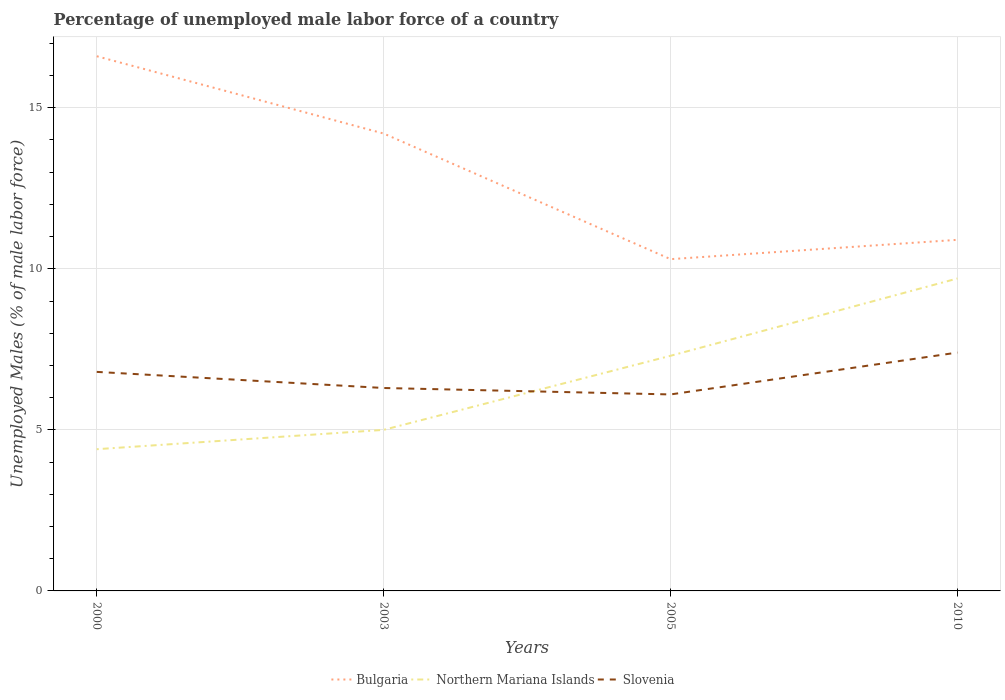How many different coloured lines are there?
Provide a succinct answer. 3. Is the number of lines equal to the number of legend labels?
Your response must be concise. Yes. Across all years, what is the maximum percentage of unemployed male labor force in Northern Mariana Islands?
Give a very brief answer. 4.4. What is the total percentage of unemployed male labor force in Northern Mariana Islands in the graph?
Your answer should be compact. -2.4. What is the difference between the highest and the second highest percentage of unemployed male labor force in Bulgaria?
Offer a very short reply. 6.3. What is the difference between the highest and the lowest percentage of unemployed male labor force in Northern Mariana Islands?
Your answer should be compact. 2. Is the percentage of unemployed male labor force in Slovenia strictly greater than the percentage of unemployed male labor force in Bulgaria over the years?
Your answer should be compact. Yes. How many lines are there?
Your answer should be very brief. 3. How many years are there in the graph?
Give a very brief answer. 4. Does the graph contain any zero values?
Provide a short and direct response. No. Does the graph contain grids?
Offer a very short reply. Yes. How many legend labels are there?
Give a very brief answer. 3. How are the legend labels stacked?
Provide a succinct answer. Horizontal. What is the title of the graph?
Offer a terse response. Percentage of unemployed male labor force of a country. What is the label or title of the Y-axis?
Offer a terse response. Unemployed Males (% of male labor force). What is the Unemployed Males (% of male labor force) in Bulgaria in 2000?
Make the answer very short. 16.6. What is the Unemployed Males (% of male labor force) in Northern Mariana Islands in 2000?
Your answer should be very brief. 4.4. What is the Unemployed Males (% of male labor force) of Slovenia in 2000?
Your answer should be compact. 6.8. What is the Unemployed Males (% of male labor force) of Bulgaria in 2003?
Your answer should be very brief. 14.2. What is the Unemployed Males (% of male labor force) of Slovenia in 2003?
Offer a terse response. 6.3. What is the Unemployed Males (% of male labor force) in Bulgaria in 2005?
Provide a short and direct response. 10.3. What is the Unemployed Males (% of male labor force) of Northern Mariana Islands in 2005?
Offer a very short reply. 7.3. What is the Unemployed Males (% of male labor force) of Slovenia in 2005?
Give a very brief answer. 6.1. What is the Unemployed Males (% of male labor force) of Bulgaria in 2010?
Make the answer very short. 10.9. What is the Unemployed Males (% of male labor force) in Northern Mariana Islands in 2010?
Make the answer very short. 9.7. What is the Unemployed Males (% of male labor force) in Slovenia in 2010?
Make the answer very short. 7.4. Across all years, what is the maximum Unemployed Males (% of male labor force) of Bulgaria?
Offer a very short reply. 16.6. Across all years, what is the maximum Unemployed Males (% of male labor force) in Northern Mariana Islands?
Make the answer very short. 9.7. Across all years, what is the maximum Unemployed Males (% of male labor force) in Slovenia?
Your response must be concise. 7.4. Across all years, what is the minimum Unemployed Males (% of male labor force) of Bulgaria?
Keep it short and to the point. 10.3. Across all years, what is the minimum Unemployed Males (% of male labor force) of Northern Mariana Islands?
Ensure brevity in your answer.  4.4. Across all years, what is the minimum Unemployed Males (% of male labor force) in Slovenia?
Your response must be concise. 6.1. What is the total Unemployed Males (% of male labor force) in Northern Mariana Islands in the graph?
Ensure brevity in your answer.  26.4. What is the total Unemployed Males (% of male labor force) of Slovenia in the graph?
Offer a very short reply. 26.6. What is the difference between the Unemployed Males (% of male labor force) of Bulgaria in 2000 and that in 2003?
Provide a succinct answer. 2.4. What is the difference between the Unemployed Males (% of male labor force) of Northern Mariana Islands in 2000 and that in 2003?
Keep it short and to the point. -0.6. What is the difference between the Unemployed Males (% of male labor force) of Slovenia in 2000 and that in 2003?
Provide a short and direct response. 0.5. What is the difference between the Unemployed Males (% of male labor force) in Bulgaria in 2000 and that in 2005?
Your answer should be compact. 6.3. What is the difference between the Unemployed Males (% of male labor force) in Northern Mariana Islands in 2000 and that in 2005?
Provide a succinct answer. -2.9. What is the difference between the Unemployed Males (% of male labor force) in Bulgaria in 2000 and that in 2010?
Provide a succinct answer. 5.7. What is the difference between the Unemployed Males (% of male labor force) of Northern Mariana Islands in 2000 and that in 2010?
Make the answer very short. -5.3. What is the difference between the Unemployed Males (% of male labor force) of Bulgaria in 2003 and that in 2005?
Provide a short and direct response. 3.9. What is the difference between the Unemployed Males (% of male labor force) in Slovenia in 2003 and that in 2005?
Ensure brevity in your answer.  0.2. What is the difference between the Unemployed Males (% of male labor force) in Bulgaria in 2003 and that in 2010?
Provide a succinct answer. 3.3. What is the difference between the Unemployed Males (% of male labor force) in Bulgaria in 2005 and that in 2010?
Give a very brief answer. -0.6. What is the difference between the Unemployed Males (% of male labor force) of Northern Mariana Islands in 2005 and that in 2010?
Your response must be concise. -2.4. What is the difference between the Unemployed Males (% of male labor force) of Slovenia in 2005 and that in 2010?
Your answer should be very brief. -1.3. What is the difference between the Unemployed Males (% of male labor force) in Bulgaria in 2000 and the Unemployed Males (% of male labor force) in Northern Mariana Islands in 2003?
Offer a terse response. 11.6. What is the difference between the Unemployed Males (% of male labor force) in Northern Mariana Islands in 2000 and the Unemployed Males (% of male labor force) in Slovenia in 2003?
Your answer should be compact. -1.9. What is the difference between the Unemployed Males (% of male labor force) in Bulgaria in 2000 and the Unemployed Males (% of male labor force) in Northern Mariana Islands in 2005?
Your response must be concise. 9.3. What is the difference between the Unemployed Males (% of male labor force) of Bulgaria in 2000 and the Unemployed Males (% of male labor force) of Slovenia in 2005?
Offer a very short reply. 10.5. What is the difference between the Unemployed Males (% of male labor force) in Northern Mariana Islands in 2000 and the Unemployed Males (% of male labor force) in Slovenia in 2005?
Ensure brevity in your answer.  -1.7. What is the difference between the Unemployed Males (% of male labor force) of Bulgaria in 2003 and the Unemployed Males (% of male labor force) of Northern Mariana Islands in 2005?
Provide a short and direct response. 6.9. What is the difference between the Unemployed Males (% of male labor force) in Northern Mariana Islands in 2003 and the Unemployed Males (% of male labor force) in Slovenia in 2005?
Offer a terse response. -1.1. What is the difference between the Unemployed Males (% of male labor force) in Bulgaria in 2003 and the Unemployed Males (% of male labor force) in Northern Mariana Islands in 2010?
Keep it short and to the point. 4.5. What is the difference between the Unemployed Males (% of male labor force) of Northern Mariana Islands in 2003 and the Unemployed Males (% of male labor force) of Slovenia in 2010?
Make the answer very short. -2.4. What is the difference between the Unemployed Males (% of male labor force) of Northern Mariana Islands in 2005 and the Unemployed Males (% of male labor force) of Slovenia in 2010?
Offer a very short reply. -0.1. What is the average Unemployed Males (% of male labor force) in Bulgaria per year?
Provide a succinct answer. 13. What is the average Unemployed Males (% of male labor force) in Slovenia per year?
Provide a short and direct response. 6.65. In the year 2000, what is the difference between the Unemployed Males (% of male labor force) of Northern Mariana Islands and Unemployed Males (% of male labor force) of Slovenia?
Provide a succinct answer. -2.4. In the year 2010, what is the difference between the Unemployed Males (% of male labor force) of Bulgaria and Unemployed Males (% of male labor force) of Slovenia?
Your response must be concise. 3.5. What is the ratio of the Unemployed Males (% of male labor force) in Bulgaria in 2000 to that in 2003?
Your response must be concise. 1.17. What is the ratio of the Unemployed Males (% of male labor force) of Slovenia in 2000 to that in 2003?
Make the answer very short. 1.08. What is the ratio of the Unemployed Males (% of male labor force) of Bulgaria in 2000 to that in 2005?
Offer a very short reply. 1.61. What is the ratio of the Unemployed Males (% of male labor force) of Northern Mariana Islands in 2000 to that in 2005?
Provide a short and direct response. 0.6. What is the ratio of the Unemployed Males (% of male labor force) in Slovenia in 2000 to that in 2005?
Offer a very short reply. 1.11. What is the ratio of the Unemployed Males (% of male labor force) of Bulgaria in 2000 to that in 2010?
Ensure brevity in your answer.  1.52. What is the ratio of the Unemployed Males (% of male labor force) in Northern Mariana Islands in 2000 to that in 2010?
Offer a very short reply. 0.45. What is the ratio of the Unemployed Males (% of male labor force) in Slovenia in 2000 to that in 2010?
Offer a terse response. 0.92. What is the ratio of the Unemployed Males (% of male labor force) in Bulgaria in 2003 to that in 2005?
Your answer should be compact. 1.38. What is the ratio of the Unemployed Males (% of male labor force) in Northern Mariana Islands in 2003 to that in 2005?
Give a very brief answer. 0.68. What is the ratio of the Unemployed Males (% of male labor force) in Slovenia in 2003 to that in 2005?
Your answer should be compact. 1.03. What is the ratio of the Unemployed Males (% of male labor force) in Bulgaria in 2003 to that in 2010?
Your answer should be compact. 1.3. What is the ratio of the Unemployed Males (% of male labor force) in Northern Mariana Islands in 2003 to that in 2010?
Provide a short and direct response. 0.52. What is the ratio of the Unemployed Males (% of male labor force) of Slovenia in 2003 to that in 2010?
Give a very brief answer. 0.85. What is the ratio of the Unemployed Males (% of male labor force) in Bulgaria in 2005 to that in 2010?
Keep it short and to the point. 0.94. What is the ratio of the Unemployed Males (% of male labor force) of Northern Mariana Islands in 2005 to that in 2010?
Your answer should be very brief. 0.75. What is the ratio of the Unemployed Males (% of male labor force) in Slovenia in 2005 to that in 2010?
Your answer should be very brief. 0.82. What is the difference between the highest and the second highest Unemployed Males (% of male labor force) in Bulgaria?
Make the answer very short. 2.4. What is the difference between the highest and the second highest Unemployed Males (% of male labor force) of Northern Mariana Islands?
Ensure brevity in your answer.  2.4. What is the difference between the highest and the lowest Unemployed Males (% of male labor force) in Northern Mariana Islands?
Make the answer very short. 5.3. What is the difference between the highest and the lowest Unemployed Males (% of male labor force) in Slovenia?
Provide a short and direct response. 1.3. 